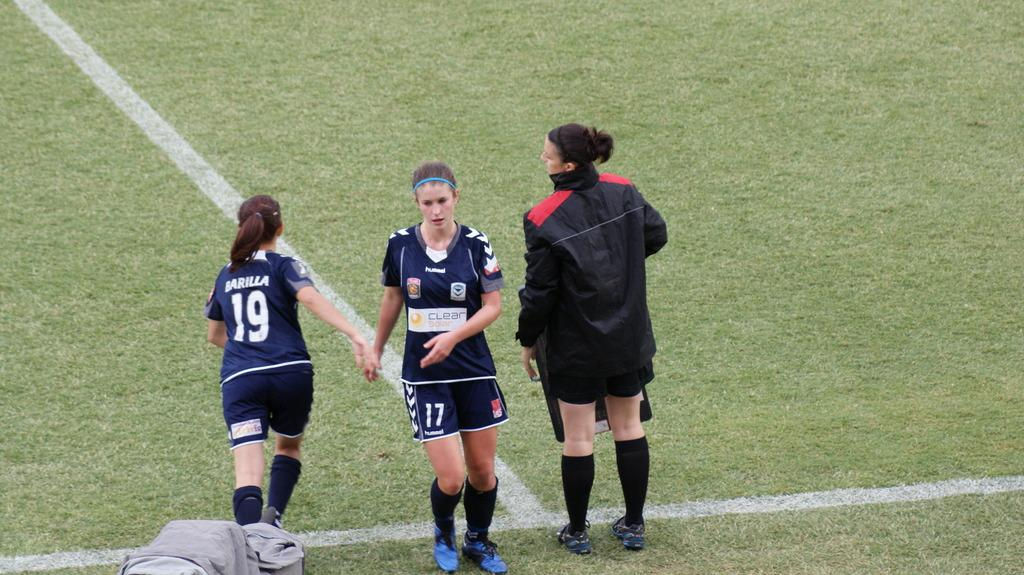What is the main activity taking place in the image? Players are standing on the grassland in the foreground area of the image. Can you describe the setting where the players are standing? The players are standing on grassland. What is located at the bottom side of the image? There is an object at the bottom side of the image. How many hearts can be seen beating in the image? There are no hearts visible in the image. What type of legs are the players using to stand on the grassland? The players' legs are not specified in the image, but it can be assumed that they are using their own legs to stand. 